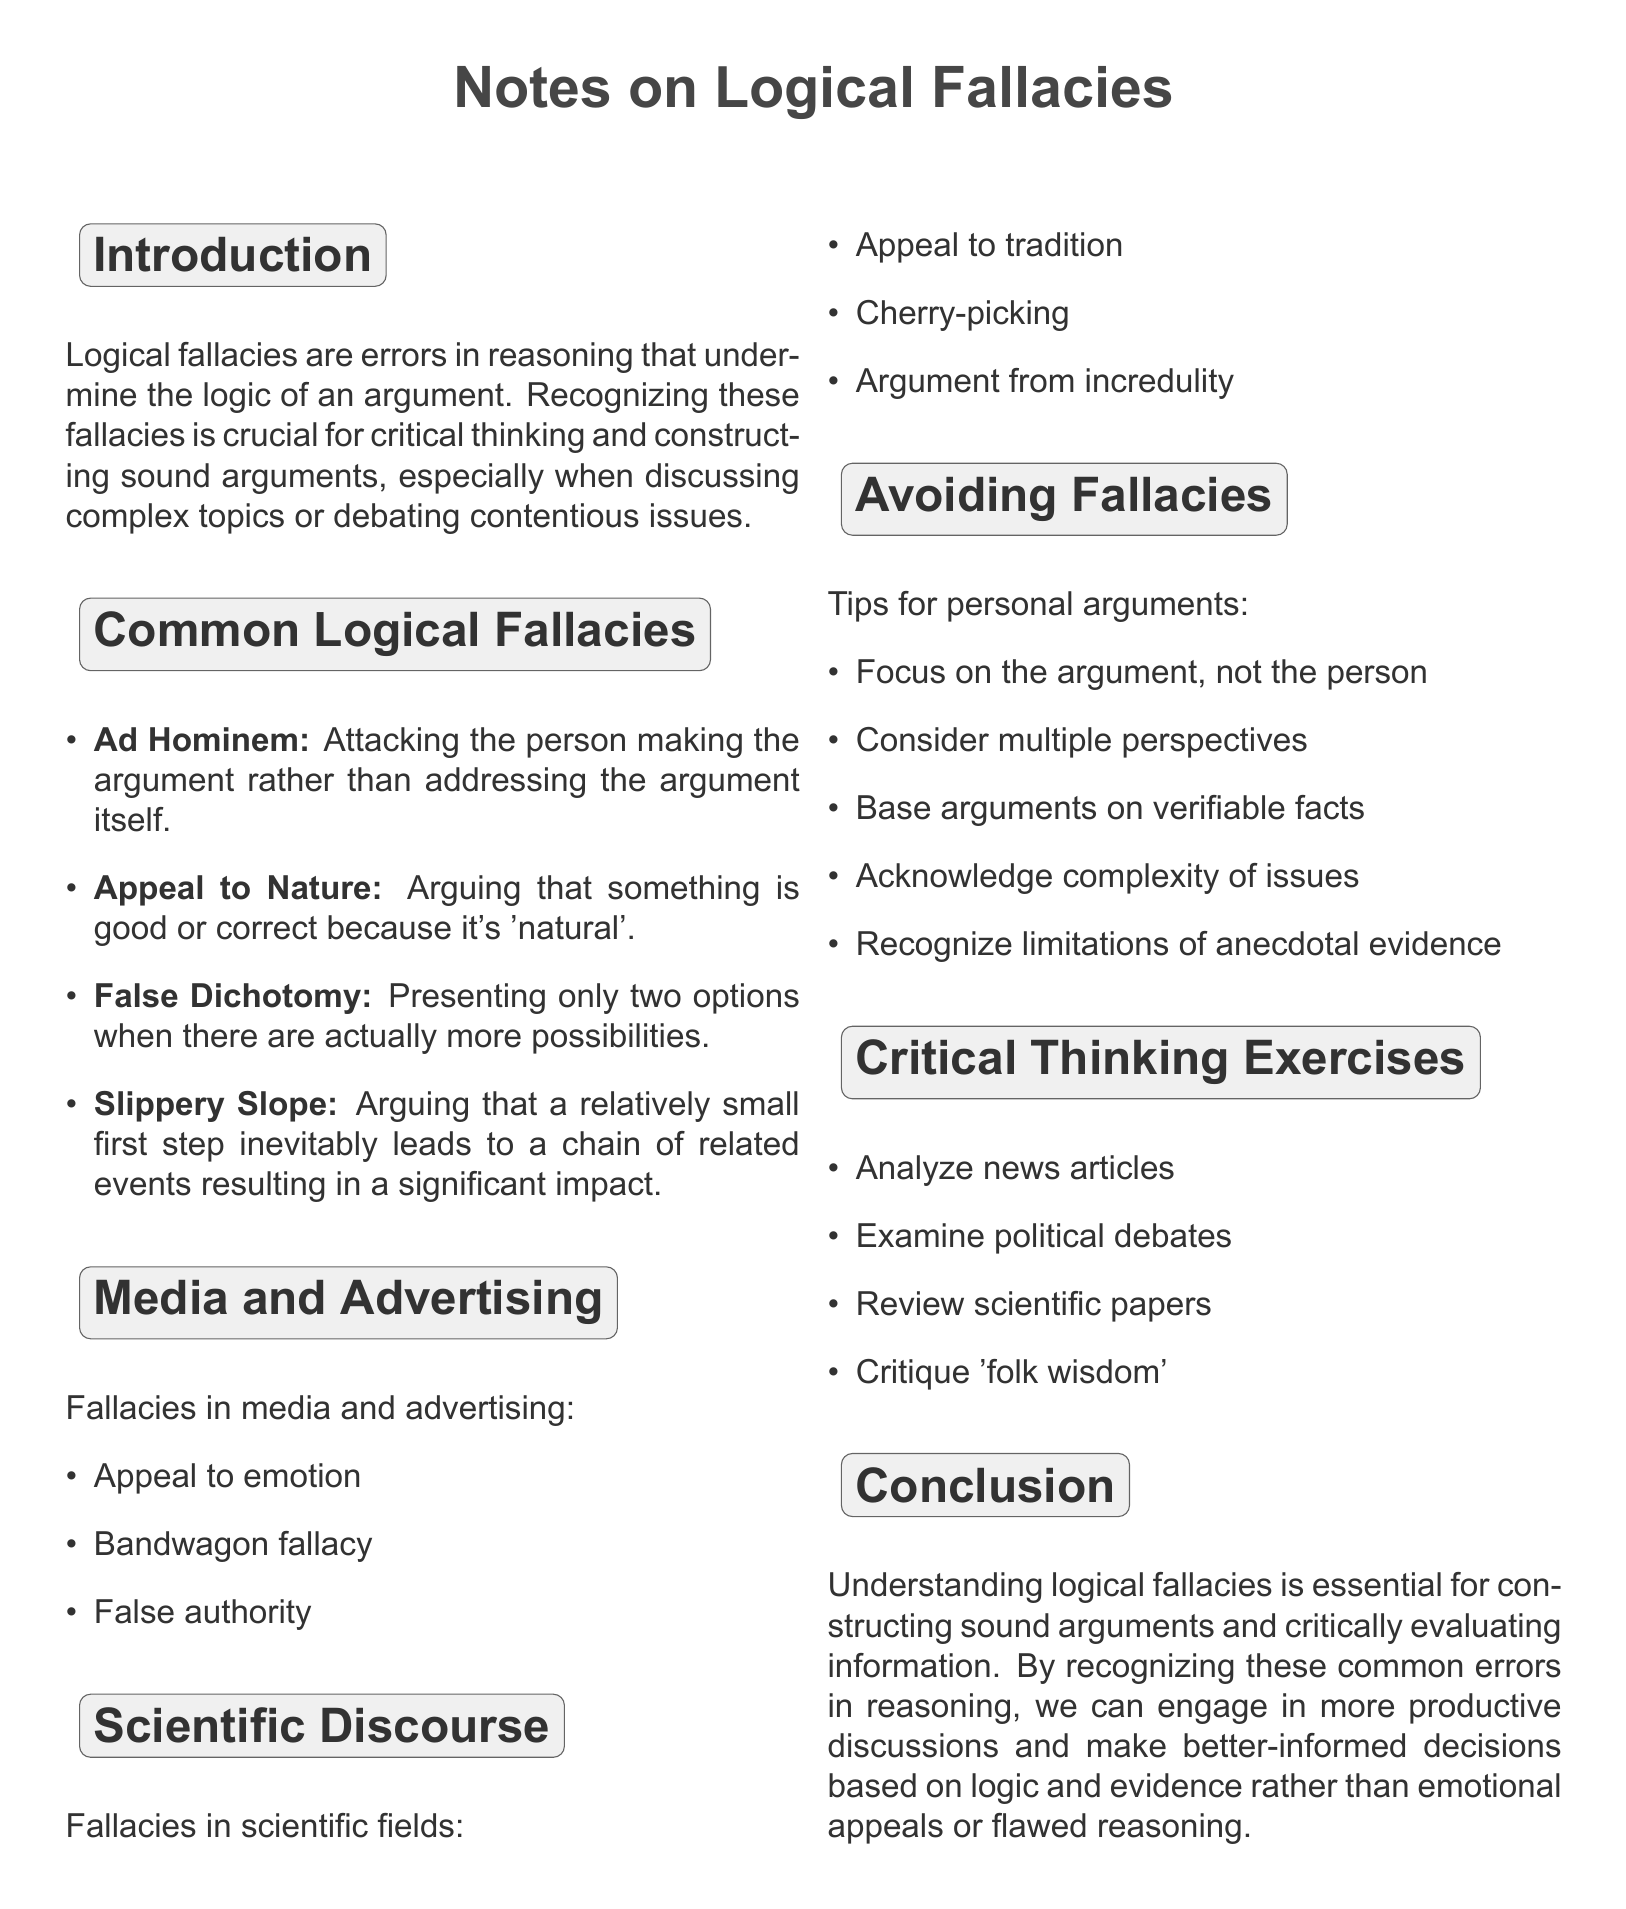What is the title of the document? The title is specified at the beginning of the document, summarizing its content related to logical fallacies.
Answer: Notes on Logical Fallacies and Their Application in Everyday Arguments What is the first logical fallacy mentioned? The document lists the common logical fallacies, starting with Ad Hominem as the first example.
Answer: Ad Hominem What is an example of False Dichotomy? The document provides a specific scenario illustrating False Dichotomy, highlighting an argument that oversimplifies options.
Answer: Arguing that either we completely ban all fossil fuels immediately or we don't care about the environment at all What is one tip for avoiding fallacies in personal arguments? The document includes several tips, one of which emphasizes the focus of argumentation.
Answer: Focus on the argument, not the person making it Name a logical fallacy used in media and advertising. The document outlines examples from media, showcasing a tactic commonly employed in advertising.
Answer: Appeal to emotion What does the introduction emphasize about logical fallacies? The introduction elaborates on the significance of logical fallacies pertaining to critical thinking and arguments.
Answer: Recognizing these fallacies is crucial for critical thinking How many exercises for critical thinking are listed? The document specifies the number of exercises that readers can engage in for analyzing arguments critically.
Answer: Four What is a common fallacy in scientific discourse? The document identifies fallacies that can emerge even within scientific discussions, mentioning one specific type.
Answer: Appeal to tradition 